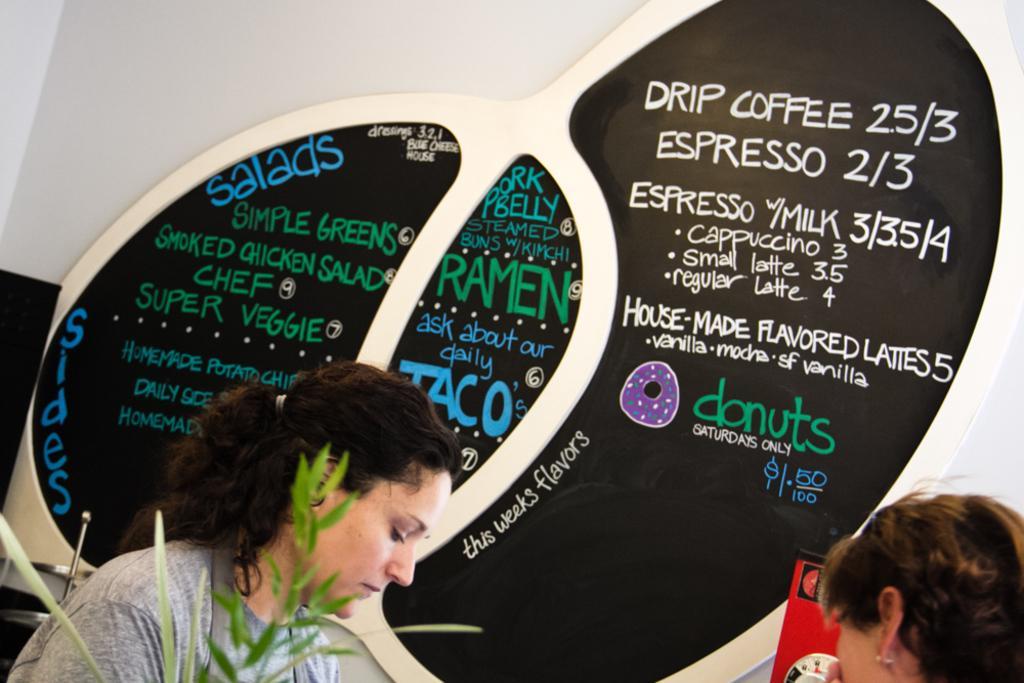Could you give a brief overview of what you see in this image? In the bottom there is a women who is wearing grey t-shirt and she is sitting near to the table. On the bottom right corner there is another woman who is sitting near to the board. In the background we can see the board which representing the prices of the food items. 